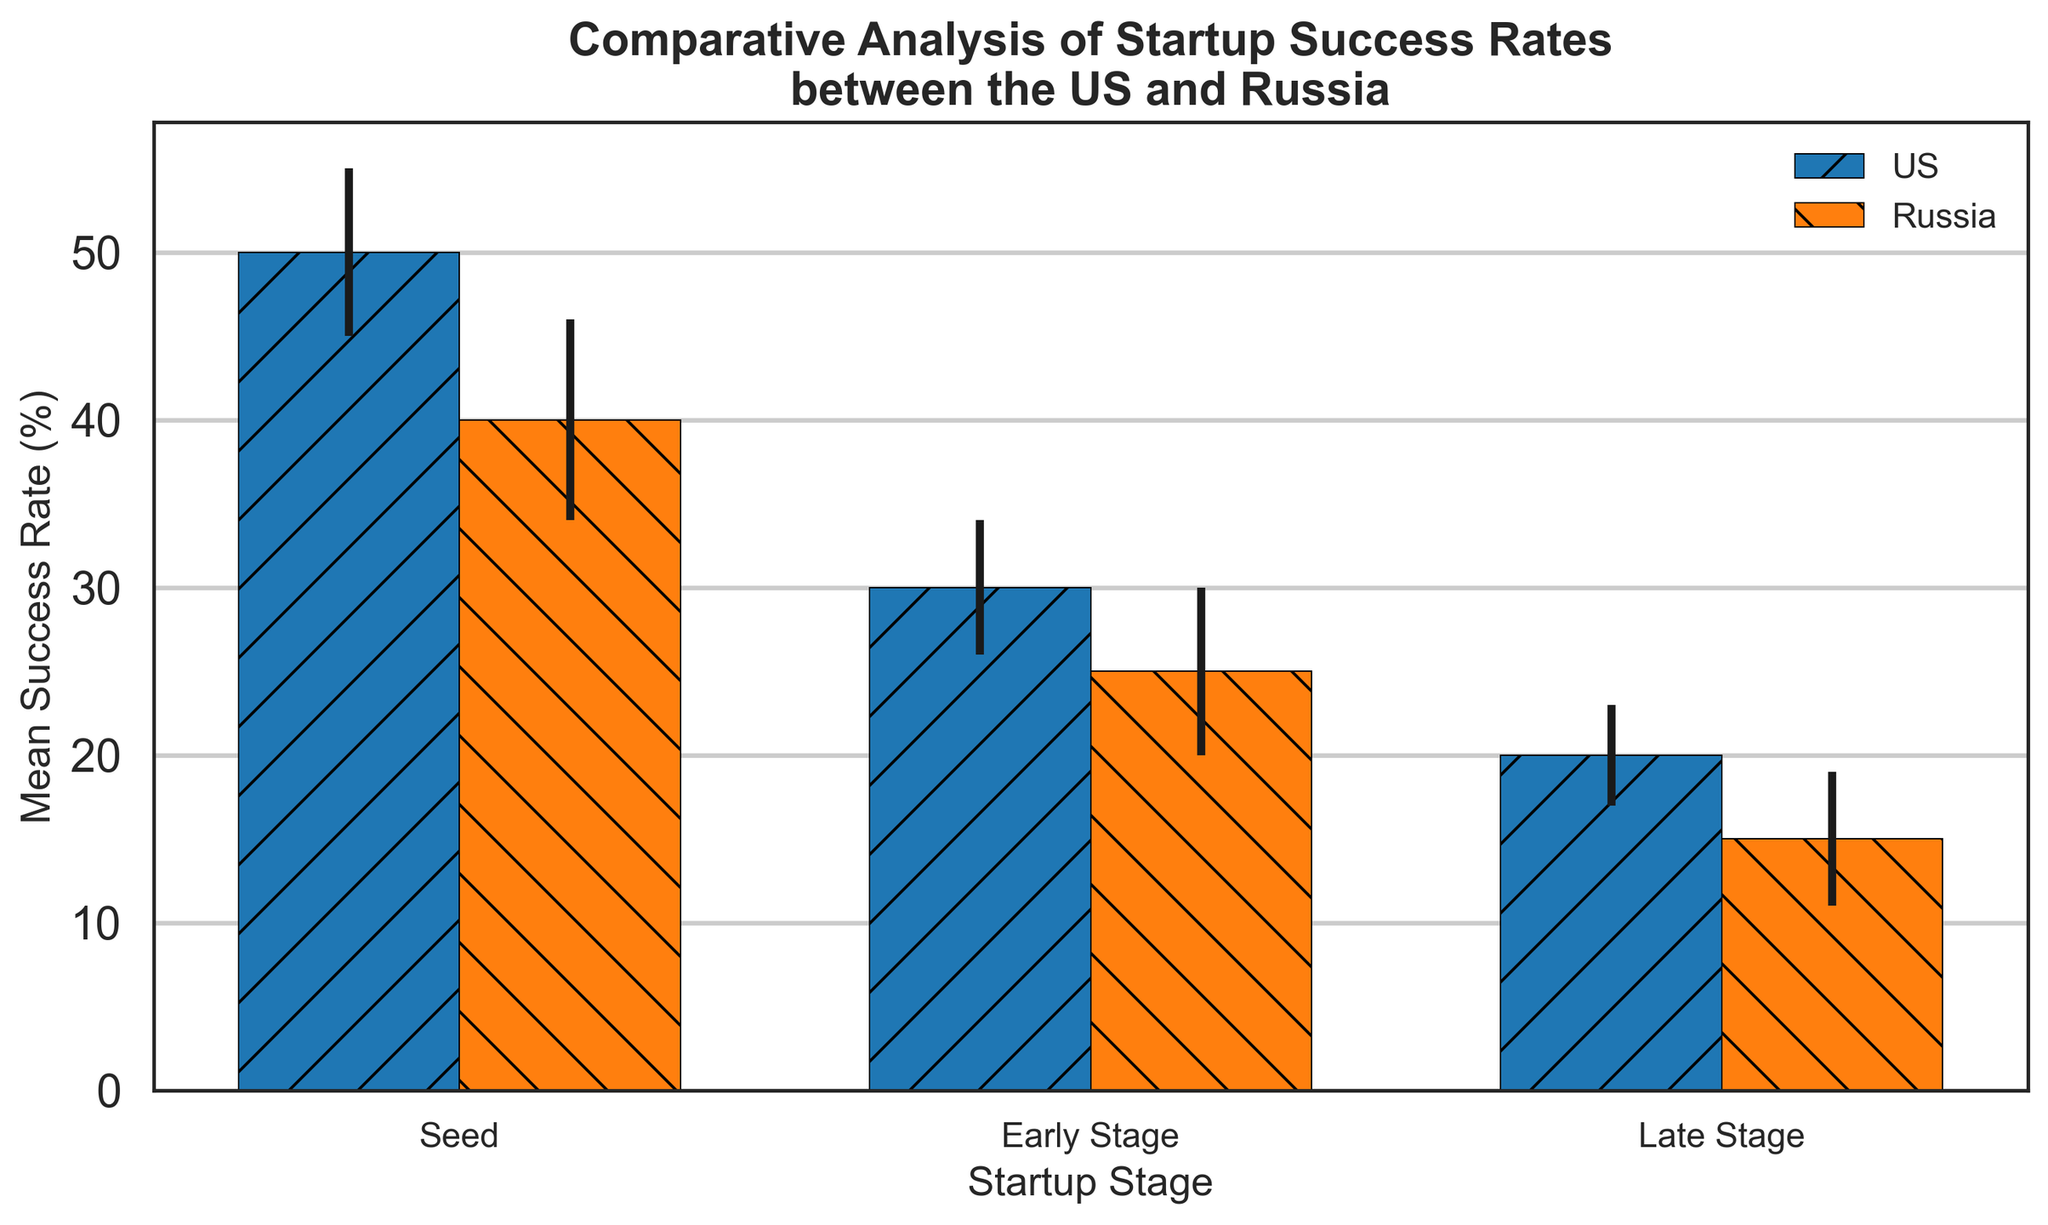Which country has a higher mean success rate at the Seed stage? By looking at the height of the two bars at the Seed stage, the US has a mean success rate of 50% while Russia has 40%.
Answer: US Which stage shows the greatest difference in mean success rates between the US and Russia? Calculate the difference in mean rates at each stage: 
Seed: 50% - 40% = 10%; 
Early Stage: 30% - 25% = 5%; 
Late Stage: 20% - 15% = 5%. 
The greatest difference is at the Seed stage (10%).
Answer: Seed What is the mean success rate of US startups in the Early Stage and Late Stage combined, and how does it compare to the sum of the corresponding stages in Russia? Sum the mean rates for the US (Early Stage: 30%, Late Stage: 20%) which is 50%. Do the same for Russia (Early Stage: 25%, Late Stage: 15%) which is 40%.
Answer: 50% for US and 40% for Russia How do the error margins at the Seed stage compare between the US and Russia? Observe the length of the error bars at the Seed stage: US has an error margin of 5%, and Russia has 6%. Russia's margin is larger by 1%.
Answer: Russia's error margin is larger What can be inferred about variability in success rates at different stages for startups in both countries? Looking at the standard deviations: 
US: Seed 5%, Early Stage 4%, Late Stage 3%; 
Russia: Seed 6%, Early Stage 5%, Late Stage 4%. 
Variability decreases as the startup progresses through stages in both countries.
Answer: Variability decreases with stage progression in both countries At which stage do Russian startups show the highest mean success rate, and what is it? Look at the Russian bars: Seed (40%), Early Stage (25%), Late Stage (15%). The highest mean rate is at the Seed stage at 40%.
Answer: Seed at 40% How does the success rate of US startups in the Late Stage compare to Russian startups in the Early Stage? Compare the heights of the respective bars: US Late Stage (20%), Russia Early Stage (25%). Russia's Early Stage is higher.
Answer: Russia's Early Stage is higher Does the trend in success rates across stages (Seed, Early, Late) appear similar or different for the US and Russia? Observe the trend lines (declining from Seed to Late): Both the US and Russia see a decrease in success rates as stages progress.
Answer: Similar trend (decreasing success rates) 